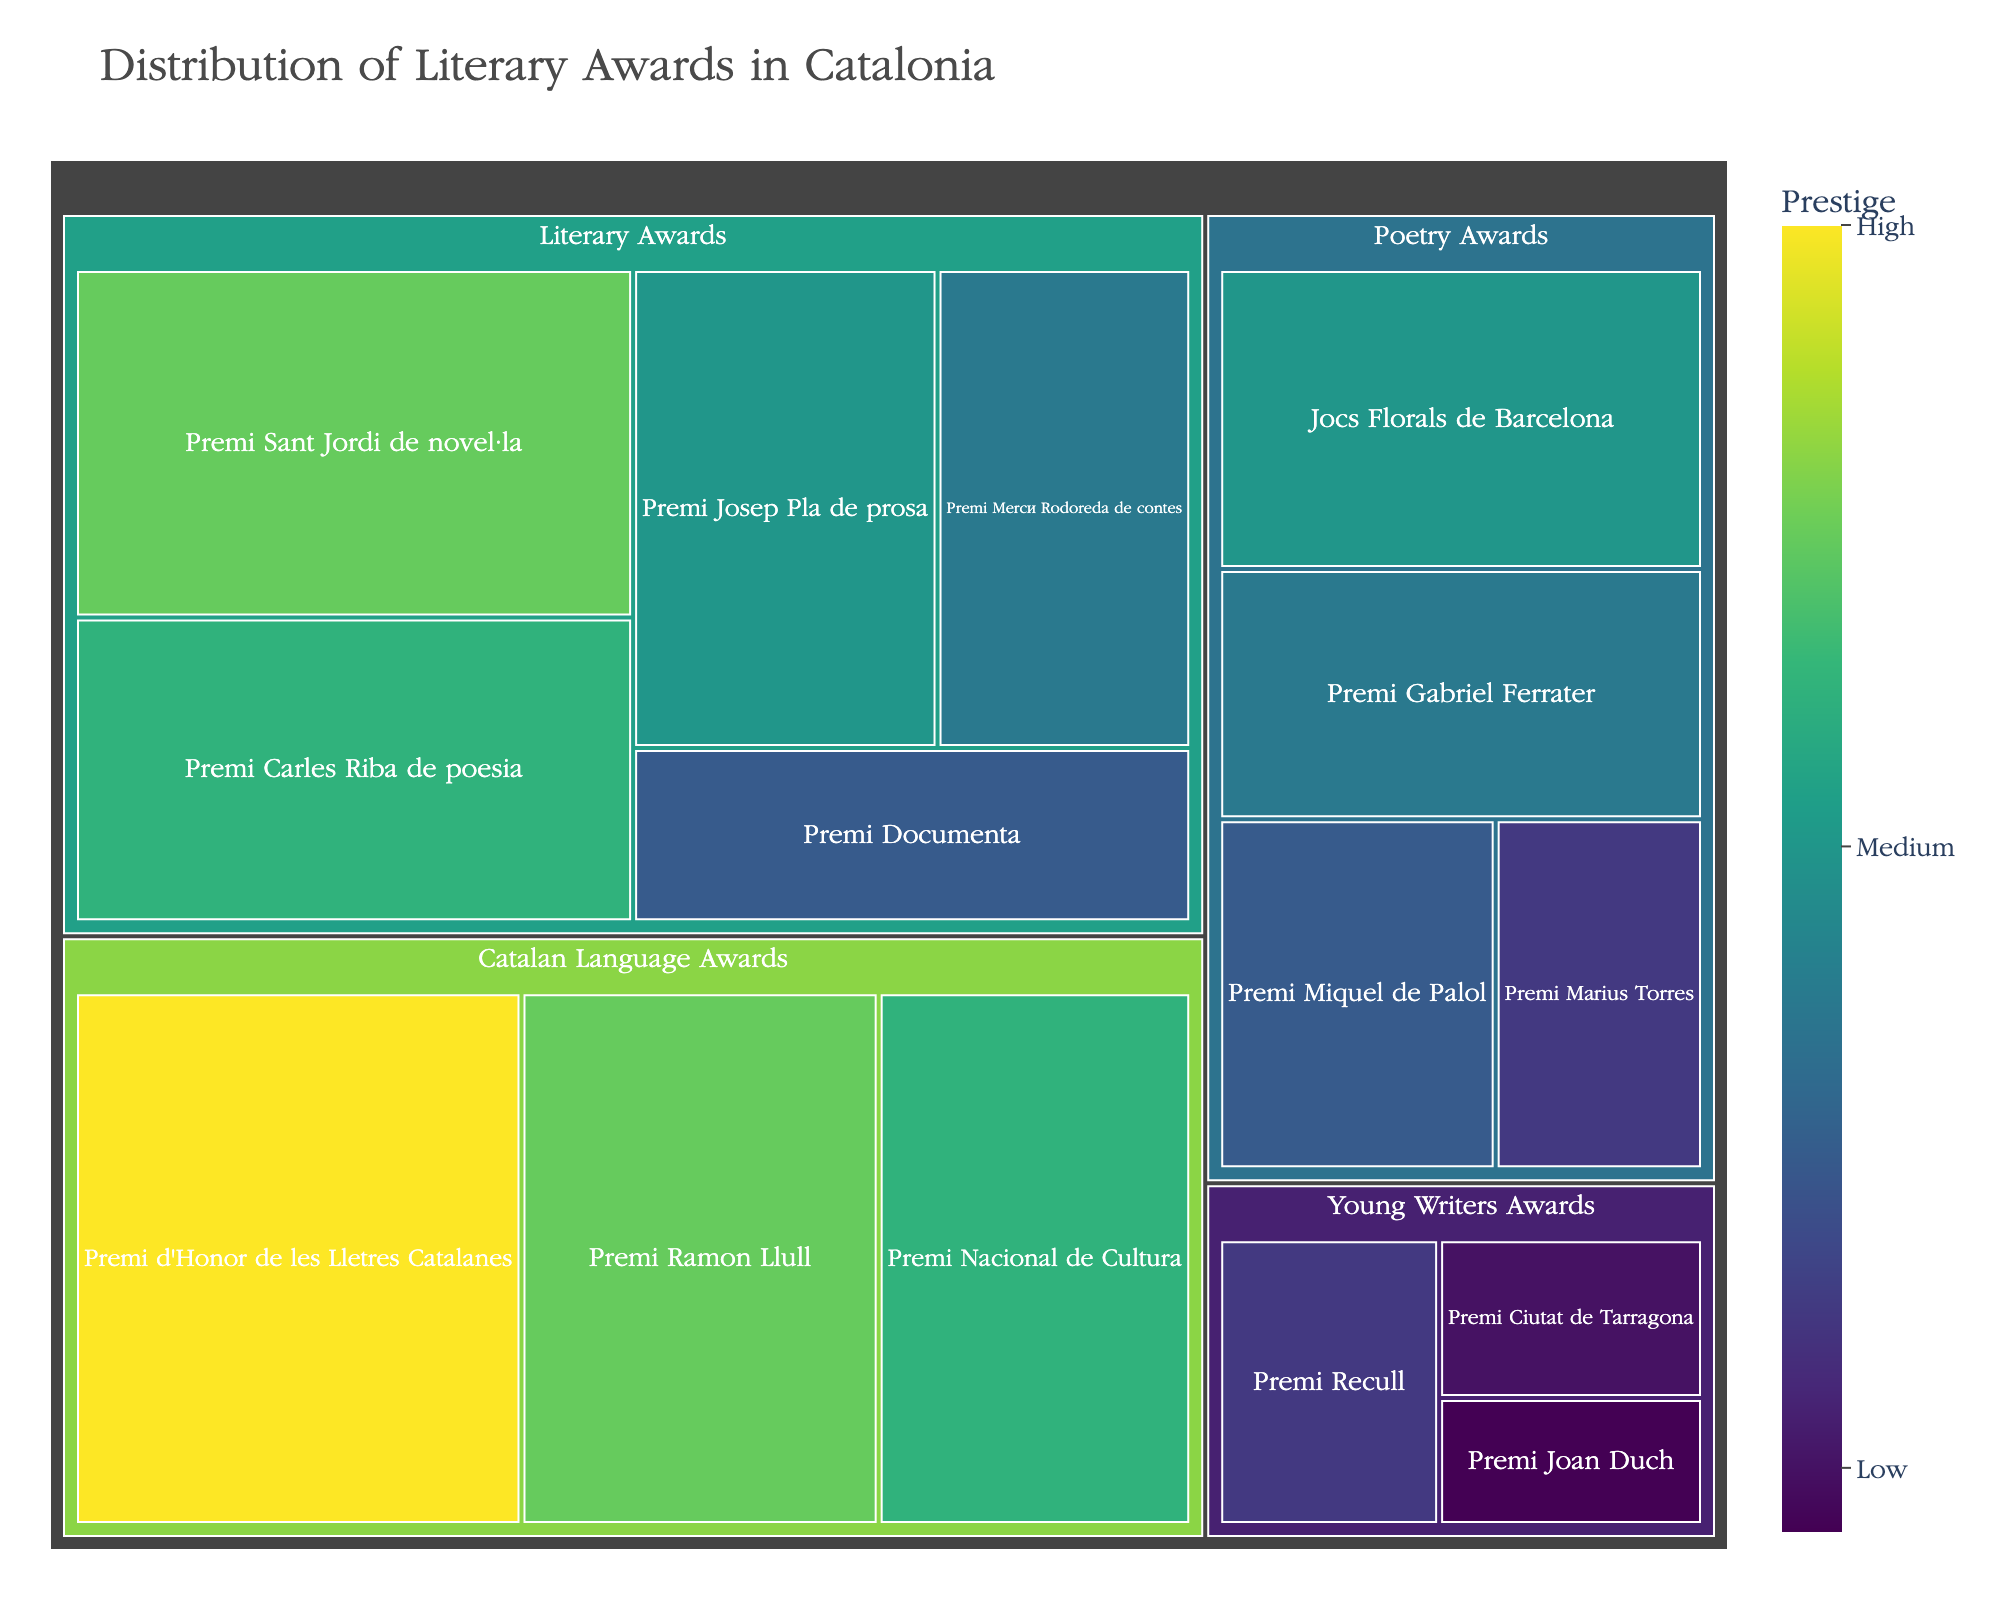what is the title of the figure? The title is located at the top center of the figure. It provides a summary of what the figure represents.
Answer: Distribution of Literary Awards in Catalonia Which award has the highest prestige in the Poetry Awards category? Look for the Poetry Awards category in the treemap, then identify the subcategory with the highest value.
Answer: Jocs Florals de Barcelona How many subcategories are there in the Catalan Language Awards category? The Catalan Language Awards category consists of different segments. Count these segments to get the subcategory count.
Answer: 3 What is the combined prestige value of the Premi Mercè Rodoreda de contes and Premi Ramon Llull? Locate these two awards in the treemap and add their prestige values together: 25 (Premi Mercè Rodoreda de contes) + 40 (Premi Ramon Llull).
Answer: 65 Which has a higher prestige value: Premi Nacional de Cultura or Premi Josep Pla de prosa? Compare the prestige values of these two awards by locating them in their respective categories.
Answer: Premi Nacional de Cultura What is the prestige difference between the most and least prestigious awards in the Young Writers Awards category? Identify the highest and lowest prestige values in the Young Writers Awards category: 15 (Premi Recull) - 8 (Premi Joan Duch).
Answer: 7 Which category contains the award with the highest overall prestige? Compare the highest prestige values in each category to find the category that includes the award with the highest value.
Answer: Catalan Language Awards List the poetry awards in ascending order of their prestige values. Arrange the poetry awards by their prestige values from smallest to largest: Premi Màrius Torres (15), Premi Miquel de Palol (20), Premi Gabriel Ferrater (25), Jocs Florals de Barcelona (30).
Answer: Premi Màrius Torres, Premi Miquel de Palol, Premi Gabriel Ferrater, Jocs Florals de Barcelona How many categories have awards with a prestige value of at least 40? Check each category for awards with a prestige value of 40 or higher. Count the qualifying categories.
Answer: 2 